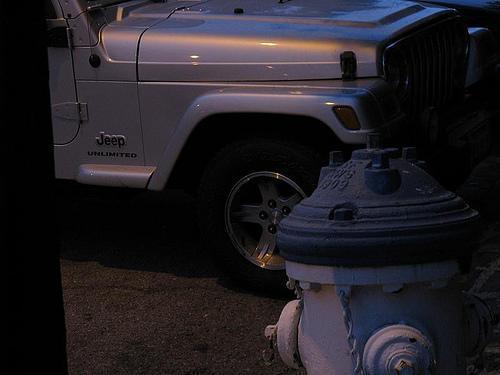How many people are pictured here?
Give a very brief answer. 0. How many vehicles are in the picture?
Give a very brief answer. 1. How many fire hydrants are seen here?
Give a very brief answer. 1. 